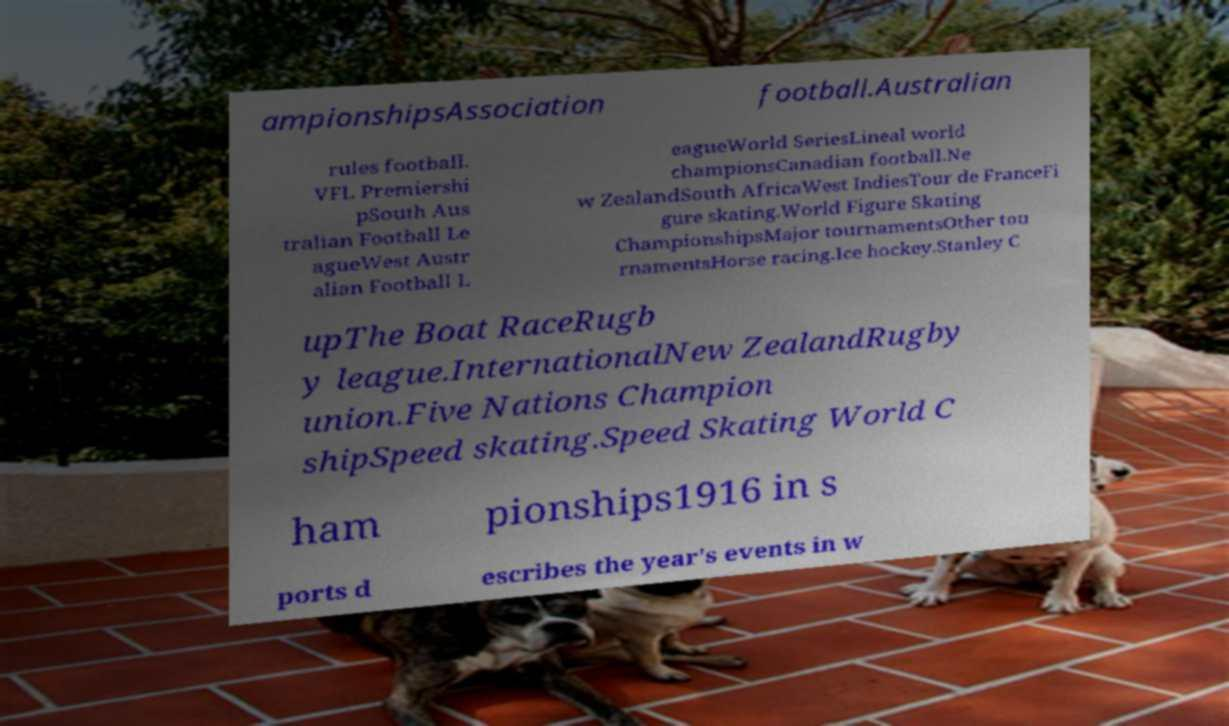Please read and relay the text visible in this image. What does it say? ampionshipsAssociation football.Australian rules football. VFL Premiershi pSouth Aus tralian Football Le agueWest Austr alian Football L eagueWorld SeriesLineal world championsCanadian football.Ne w ZealandSouth AfricaWest IndiesTour de FranceFi gure skating.World Figure Skating ChampionshipsMajor tournamentsOther tou rnamentsHorse racing.Ice hockey.Stanley C upThe Boat RaceRugb y league.InternationalNew ZealandRugby union.Five Nations Champion shipSpeed skating.Speed Skating World C ham pionships1916 in s ports d escribes the year's events in w 